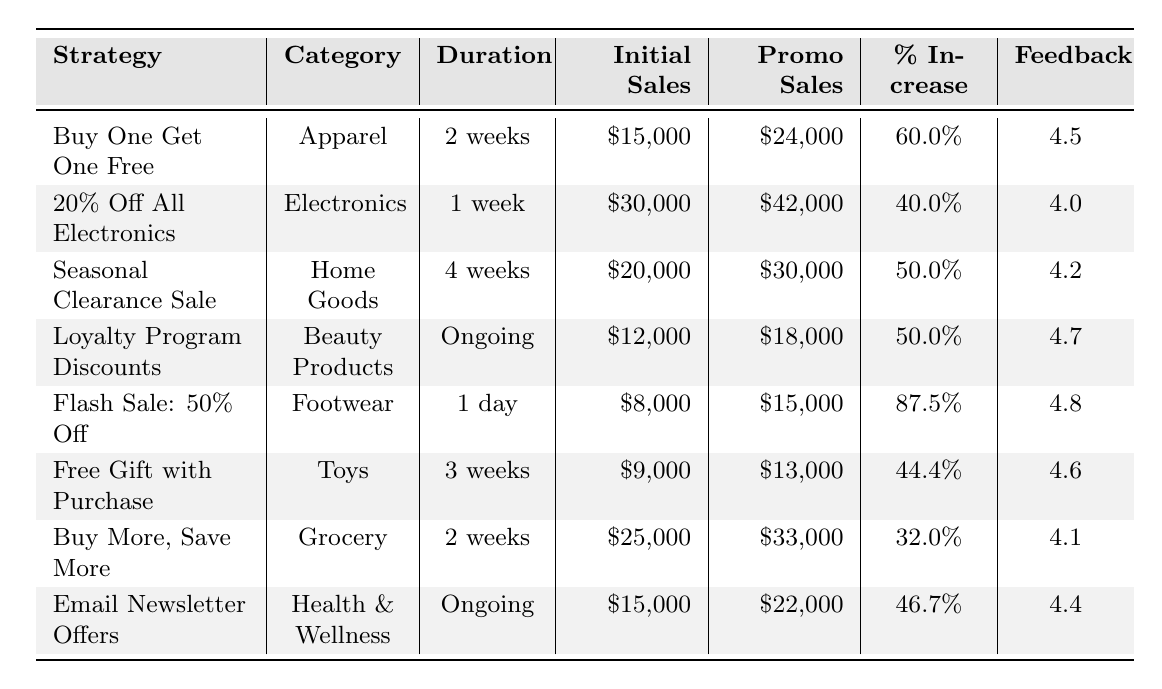What is the percentage increase in sales for the "Flash Sale: 50% Off" strategy? The table shows that the percentage increase for the "Flash Sale: 50% Off" is listed directly as 87.5%.
Answer: 87.5% Which promotional strategy had the highest customer feedback score? The "Flash Sale: 50% Off" has a customer feedback score of 4.8, which is the highest among all strategies listed.
Answer: 4.8 What is the percentage increase for the "Buy More, Save More" strategy? The table indicates that the percentage increase for the "Buy More, Save More" strategy is 32%.
Answer: 32% How many weeks did the "Seasonal Clearance Sale" last? According to the table, the duration of the "Seasonal Clearance Sale" is noted as 4 weeks.
Answer: 4 weeks Which category had the lowest initial sales? Upon examining the initial sales listed in the table, "Footwear" had the lowest initial sales at $8,000.
Answer: $8,000 What is the average percentage increase of all promotional strategies? Summing up all percentage increases: 60 + 40 + 50 + 50 + 87.5 + 44.4 + 32 + 46.7 = 410.6. There are 8 strategies, so the average is 410.6 / 8 = 51.325%.
Answer: 51.325% Is the customer feedback score for "Buy One Get One Free" higher than the score for "20% Off All Electronics"? The score for "Buy One Get One Free" is 4.5, while the score for "20% Off All Electronics" is 4.0. Since 4.5 is greater than 4.0, the statement is true.
Answer: Yes If we consider all strategies, what are the total initial sales across all categories? Adding up all initial sales: 15000 + 30000 + 20000 + 12000 + 8000 + 9000 + 25000 + 15000 = 111000.
Answer: $111,000 Which promotional strategy generated a percentage increase between 40% and 50%? Examining the percentage increases, "20% Off All Electronics" at 40% and "Free Gift with Purchase" at 44.4% have increases within that range.
Answer: 20% Off All Electronics, Free Gift with Purchase What is the duration of the "Loyalty Program Discounts" strategy? The table indicates that the "Loyalty Program Discounts" strategy is ongoing, meaning there is no defined end duration.
Answer: Ongoing 